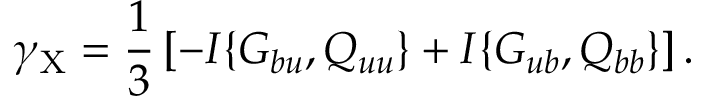<formula> <loc_0><loc_0><loc_500><loc_500>\gamma _ { X } = \frac { 1 } { 3 } \left [ { - I \{ { G _ { b u } , Q _ { u u } } \} + I \{ { G _ { u b } , Q _ { b b } } \} } \right ] .</formula> 